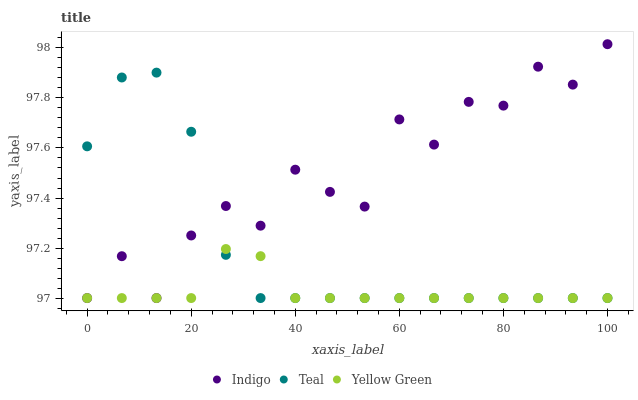Does Yellow Green have the minimum area under the curve?
Answer yes or no. Yes. Does Indigo have the maximum area under the curve?
Answer yes or no. Yes. Does Teal have the minimum area under the curve?
Answer yes or no. No. Does Teal have the maximum area under the curve?
Answer yes or no. No. Is Yellow Green the smoothest?
Answer yes or no. Yes. Is Indigo the roughest?
Answer yes or no. Yes. Is Teal the smoothest?
Answer yes or no. No. Is Teal the roughest?
Answer yes or no. No. Does Indigo have the lowest value?
Answer yes or no. Yes. Does Indigo have the highest value?
Answer yes or no. Yes. Does Teal have the highest value?
Answer yes or no. No. Does Teal intersect Indigo?
Answer yes or no. Yes. Is Teal less than Indigo?
Answer yes or no. No. Is Teal greater than Indigo?
Answer yes or no. No. 